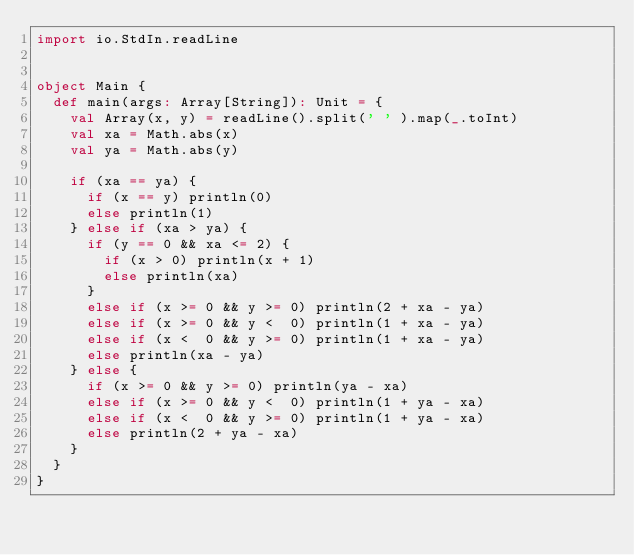Convert code to text. <code><loc_0><loc_0><loc_500><loc_500><_Scala_>import io.StdIn.readLine


object Main {
  def main(args: Array[String]): Unit = {
    val Array(x, y) = readLine().split(' ' ).map(_.toInt)
    val xa = Math.abs(x)
    val ya = Math.abs(y)

    if (xa == ya) {
      if (x == y) println(0)
      else println(1)
    } else if (xa > ya) {
      if (y == 0 && xa <= 2) {
        if (x > 0) println(x + 1)
        else println(xa)
      }
      else if (x >= 0 && y >= 0) println(2 + xa - ya)
      else if (x >= 0 && y <  0) println(1 + xa - ya)
      else if (x <  0 && y >= 0) println(1 + xa - ya)
      else println(xa - ya)
    } else {
      if (x >= 0 && y >= 0) println(ya - xa)
      else if (x >= 0 && y <  0) println(1 + ya - xa)
      else if (x <  0 && y >= 0) println(1 + ya - xa)
      else println(2 + ya - xa)
    }
  }
}
</code> 